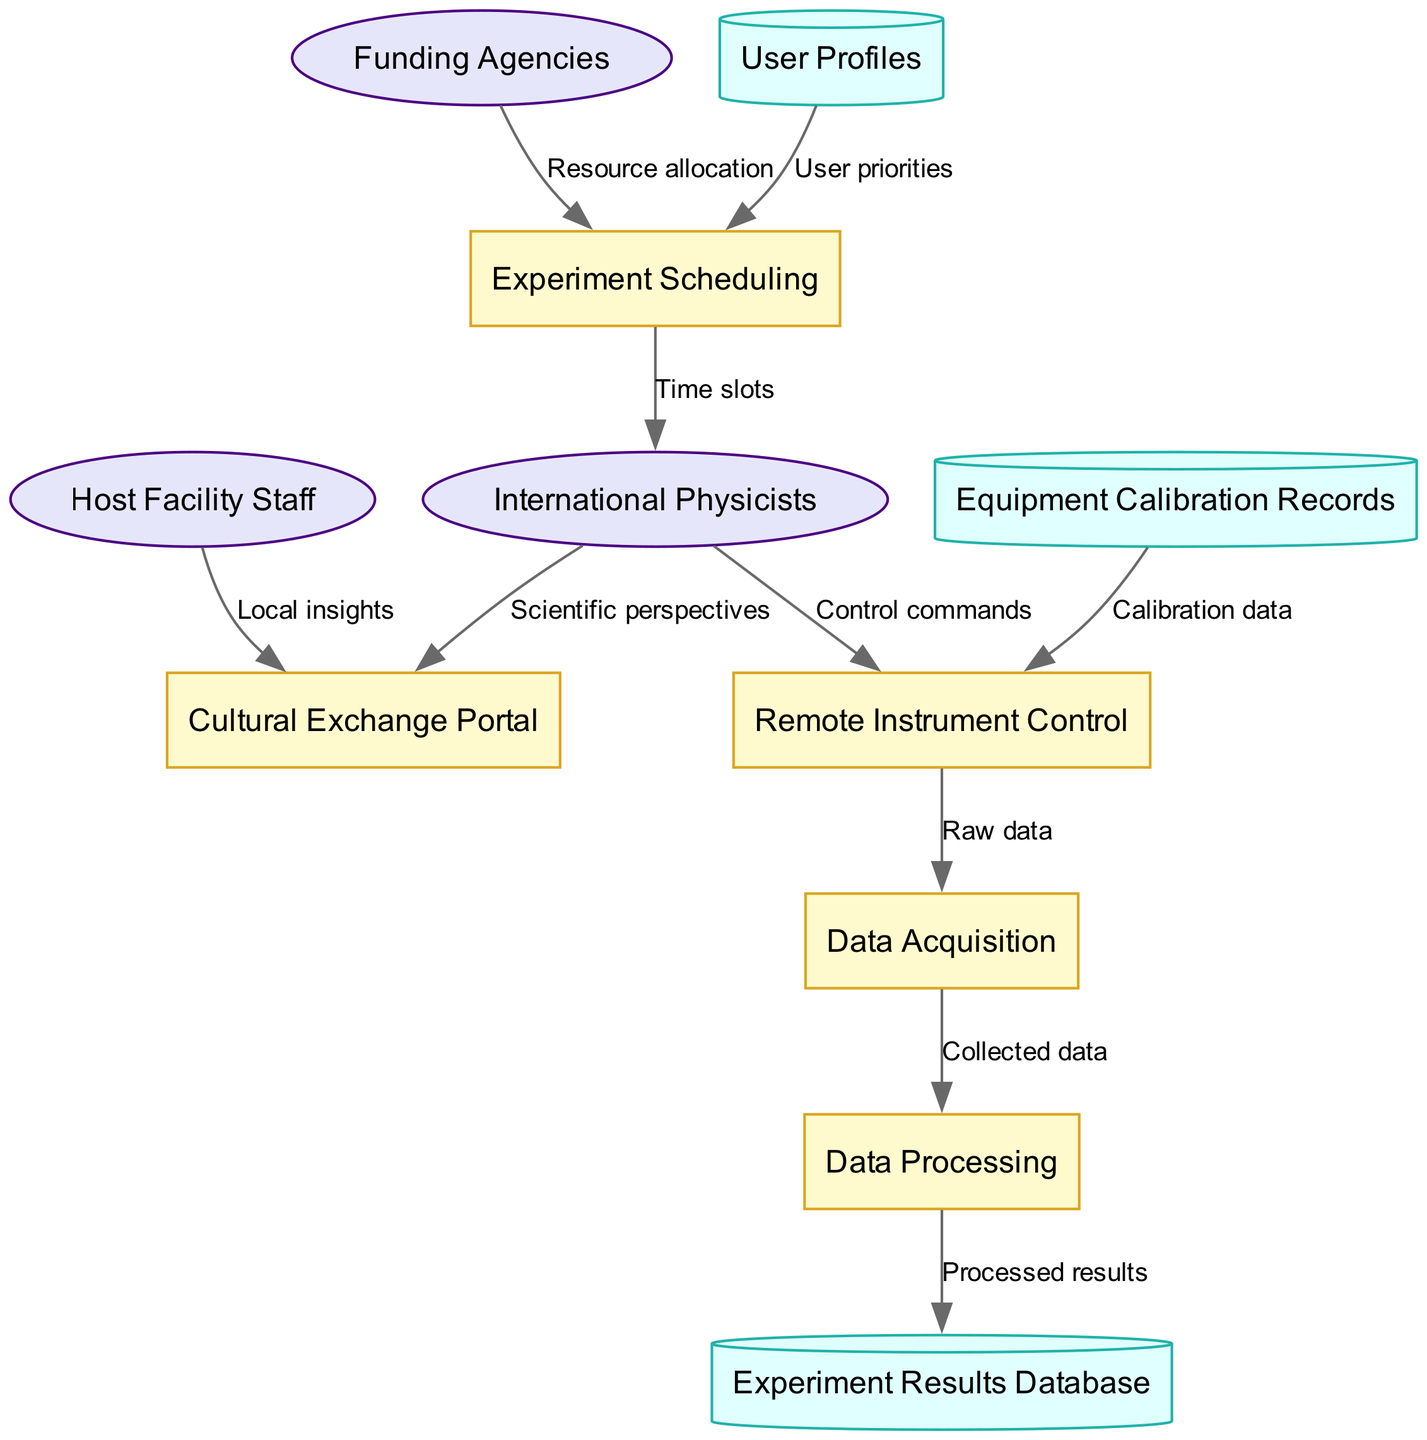What are the processes involved in the system? The diagram lists five processes: Remote Instrument Control, Data Acquisition, Data Processing, Cultural Exchange Portal, and Experiment Scheduling.
Answer: Remote Instrument Control, Data Acquisition, Data Processing, Cultural Exchange Portal, Experiment Scheduling How many external entities are present? The diagram shows three external entities: International Physicists, Host Facility Staff, and Funding Agencies. Counting these gives a total of three.
Answer: 3 What data flows from International Physicists to Data Processing? From the diagram, the only direct flow from International Physicists is to Remote Instrument Control and then to Data Acquisition, followed by Data Processing. Thus, "Collected data" is the flow reaching Data Processing.
Answer: Collected data What does the Host Facility Staff provide to the Cultural Exchange Portal? The data flow indicates that Host Facility Staff sends "Local insights" to the Cultural Exchange Portal.
Answer: Local insights Which data store receives data from Data Processing? According to the diagram, Data Processing sends "Processed results" to the Experiment Results Database, indicating this relationship.
Answer: Experiment Results Database What is the relationship between Experiment Scheduling and International Physicists? The flow from Experiment Scheduling to International Physicists is described as "Time slots," indicating scheduling information provided to physicists.
Answer: Time slots What type of information do Funding Agencies provide to Experiment Scheduling? The diagram indicates that Funding Agencies provide "Resource allocation" to Experiment Scheduling, which impacts scheduling decisions.
Answer: Resource allocation How many data stores are depicted in the diagram? The diagram includes three data stores: Experiment Results Database, User Profiles, and Equipment Calibration Records.
Answer: 3 What type of entity is Remote Instrument Control classified as? In the diagram, Remote Instrument Control is defined as a process, specifically outlined as part of controlling instruments remotely.
Answer: Process 